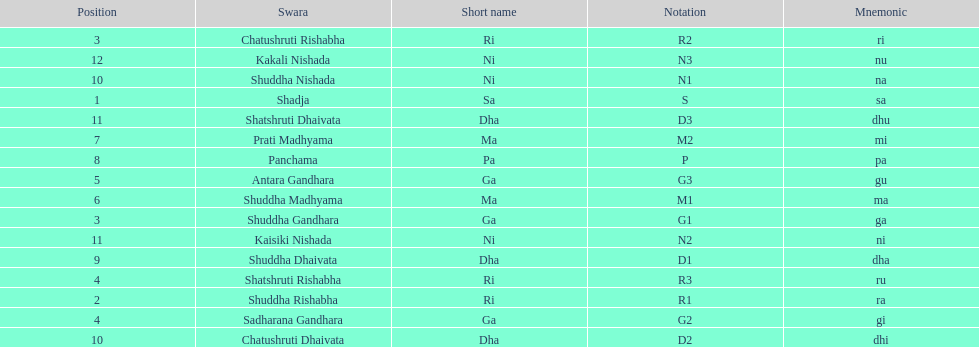Other than m1 how many notations have "1" in them? 4. 